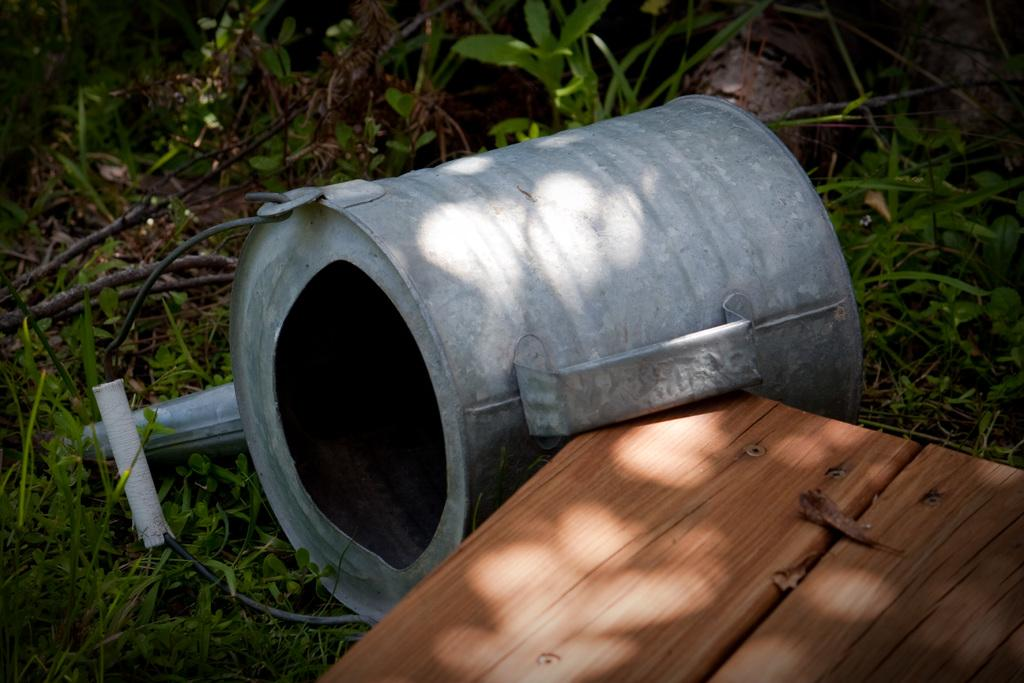What is the color of the first object in the image? The first object in the image is ash-colored. What is the color of the second object in the image? The second object in the image is brown-colored and made of wood. Where are both objects located in the image? Both objects are on the grass in the image. What else can be seen in the image besides the two objects? There is a wire visible in the image. What type of mask is being worn by the ash-colored object in the image? There is no mask present in the image, and the ash-colored object is not a living being that could wear a mask. 